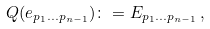<formula> <loc_0><loc_0><loc_500><loc_500>Q ( e _ { p _ { 1 } \dots p _ { n - 1 } } ) \colon = { E } _ { p _ { 1 } \dots p _ { n - 1 } } \, ,</formula> 